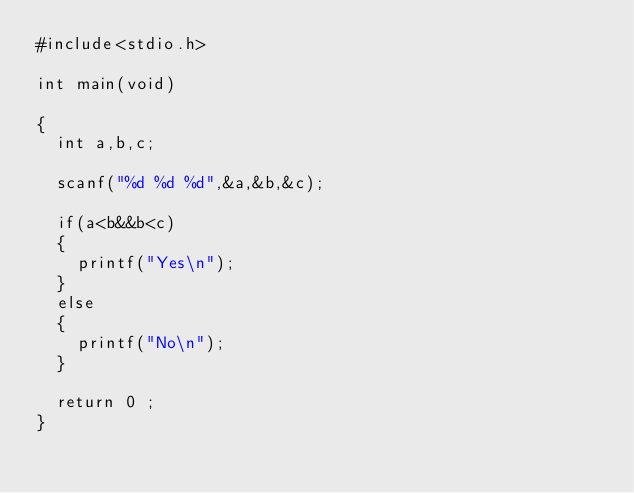Convert code to text. <code><loc_0><loc_0><loc_500><loc_500><_C_>#include<stdio.h>

int main(void)

{
	int a,b,c;
	
	scanf("%d %d %d",&a,&b,&c);
	
	if(a<b&&b<c)
	{
		printf("Yes\n");
	}
	else
	{
		printf("No\n");
	}
	
	return 0 ;
}</code> 